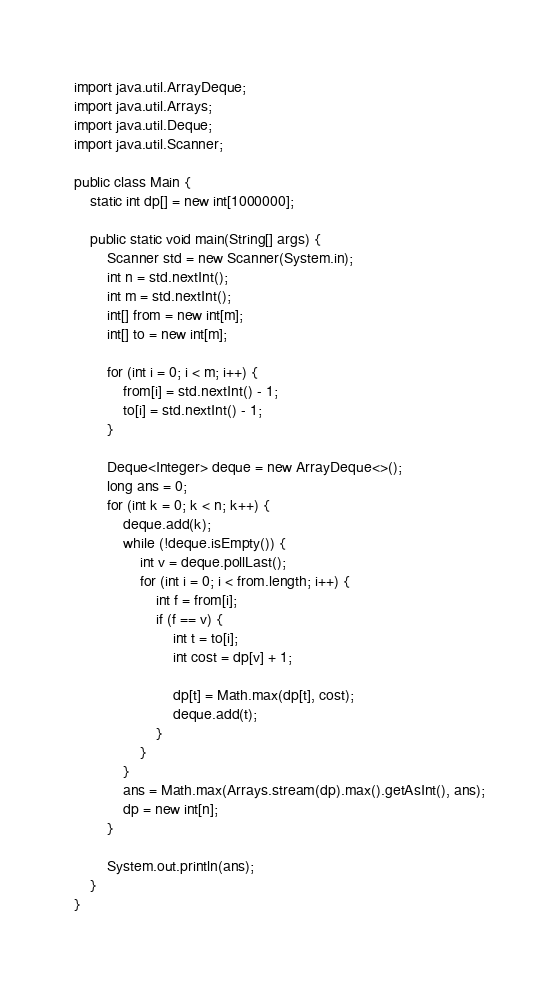Convert code to text. <code><loc_0><loc_0><loc_500><loc_500><_Java_>import java.util.ArrayDeque;
import java.util.Arrays;
import java.util.Deque;
import java.util.Scanner;

public class Main {
    static int dp[] = new int[1000000];

    public static void main(String[] args) {
        Scanner std = new Scanner(System.in);
        int n = std.nextInt();
        int m = std.nextInt();
        int[] from = new int[m];
        int[] to = new int[m];

        for (int i = 0; i < m; i++) {
            from[i] = std.nextInt() - 1;
            to[i] = std.nextInt() - 1;
        }

        Deque<Integer> deque = new ArrayDeque<>();
        long ans = 0;
        for (int k = 0; k < n; k++) {
            deque.add(k);
            while (!deque.isEmpty()) {
                int v = deque.pollLast();
                for (int i = 0; i < from.length; i++) {
                    int f = from[i];
                    if (f == v) {
                        int t = to[i];
                        int cost = dp[v] + 1;

                        dp[t] = Math.max(dp[t], cost);
                        deque.add(t);
                    }
                }
            }
            ans = Math.max(Arrays.stream(dp).max().getAsInt(), ans);
            dp = new int[n];
        }

        System.out.println(ans);
    }
}</code> 